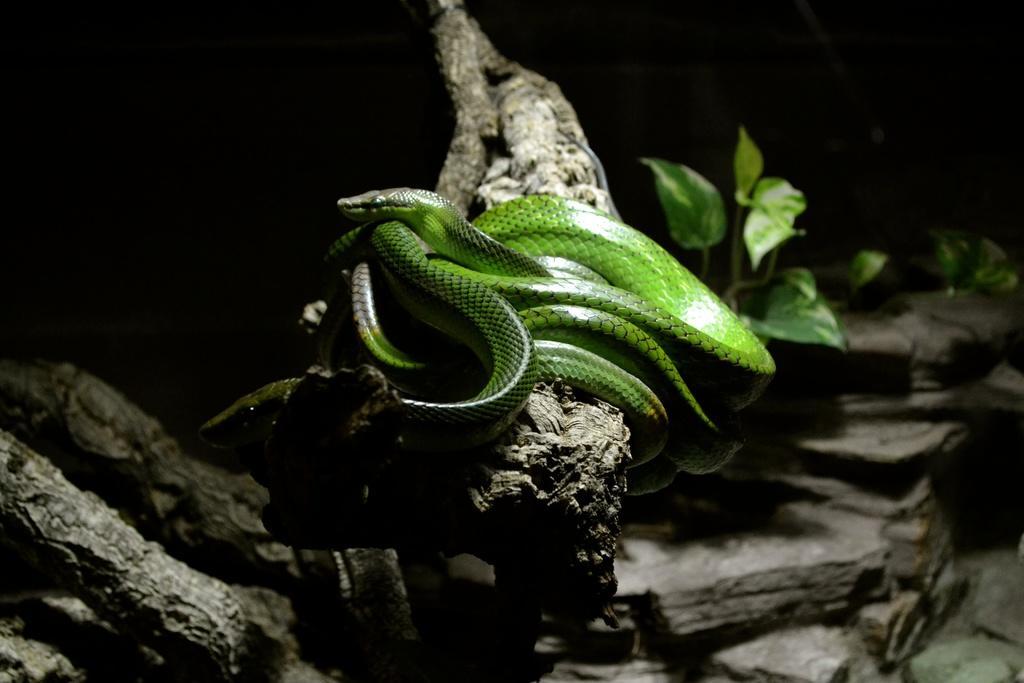How would you summarize this image in a sentence or two? In this image we can see there is a green snake on the branch of a tree and on the right side there is a plant. 